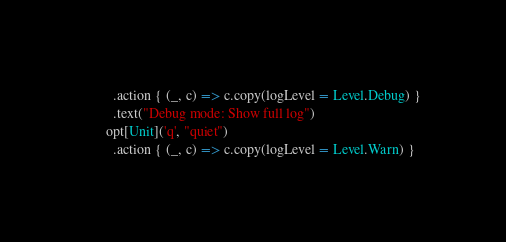<code> <loc_0><loc_0><loc_500><loc_500><_Scala_>        .action { (_, c) => c.copy(logLevel = Level.Debug) }
        .text("Debug mode: Show full log")
      opt[Unit]('q', "quiet")
        .action { (_, c) => c.copy(logLevel = Level.Warn) }</code> 